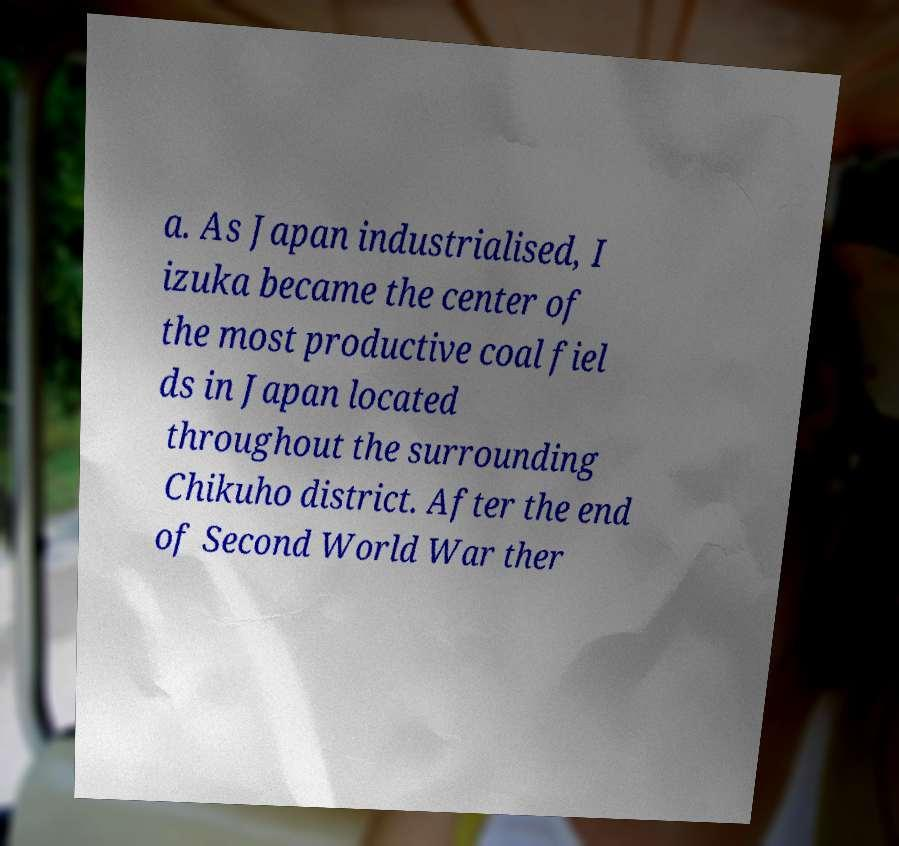Can you accurately transcribe the text from the provided image for me? a. As Japan industrialised, I izuka became the center of the most productive coal fiel ds in Japan located throughout the surrounding Chikuho district. After the end of Second World War ther 